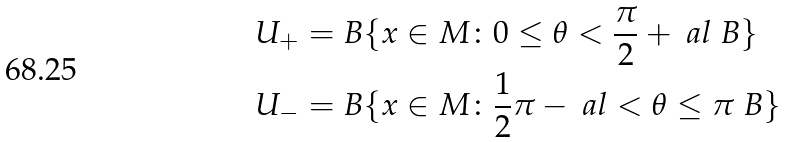Convert formula to latex. <formula><loc_0><loc_0><loc_500><loc_500>U _ { + } = & \ B \{ x \in M \colon 0 \leq \theta < \frac { \pi } { 2 } + \ a l \ B \} \\ U _ { - } = & \ B \{ x \in M \colon \frac { 1 } { 2 } \pi - \ a l < \theta \leq \pi \ B \} \\</formula> 